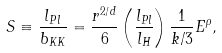<formula> <loc_0><loc_0><loc_500><loc_500>S \equiv \frac { l _ { P l } } { b _ { K K } } = \frac { r ^ { 2 / d } } { 6 } \left ( \frac { l _ { P l } } { l _ { H } } \right ) \frac { 1 } { k / 3 } E ^ { \rho } ,</formula> 